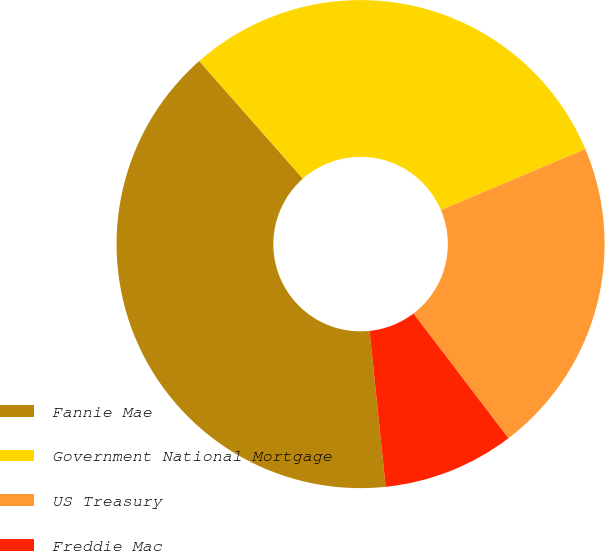Convert chart. <chart><loc_0><loc_0><loc_500><loc_500><pie_chart><fcel>Fannie Mae<fcel>Government National Mortgage<fcel>US Treasury<fcel>Freddie Mac<nl><fcel>40.14%<fcel>30.13%<fcel>21.01%<fcel>8.72%<nl></chart> 